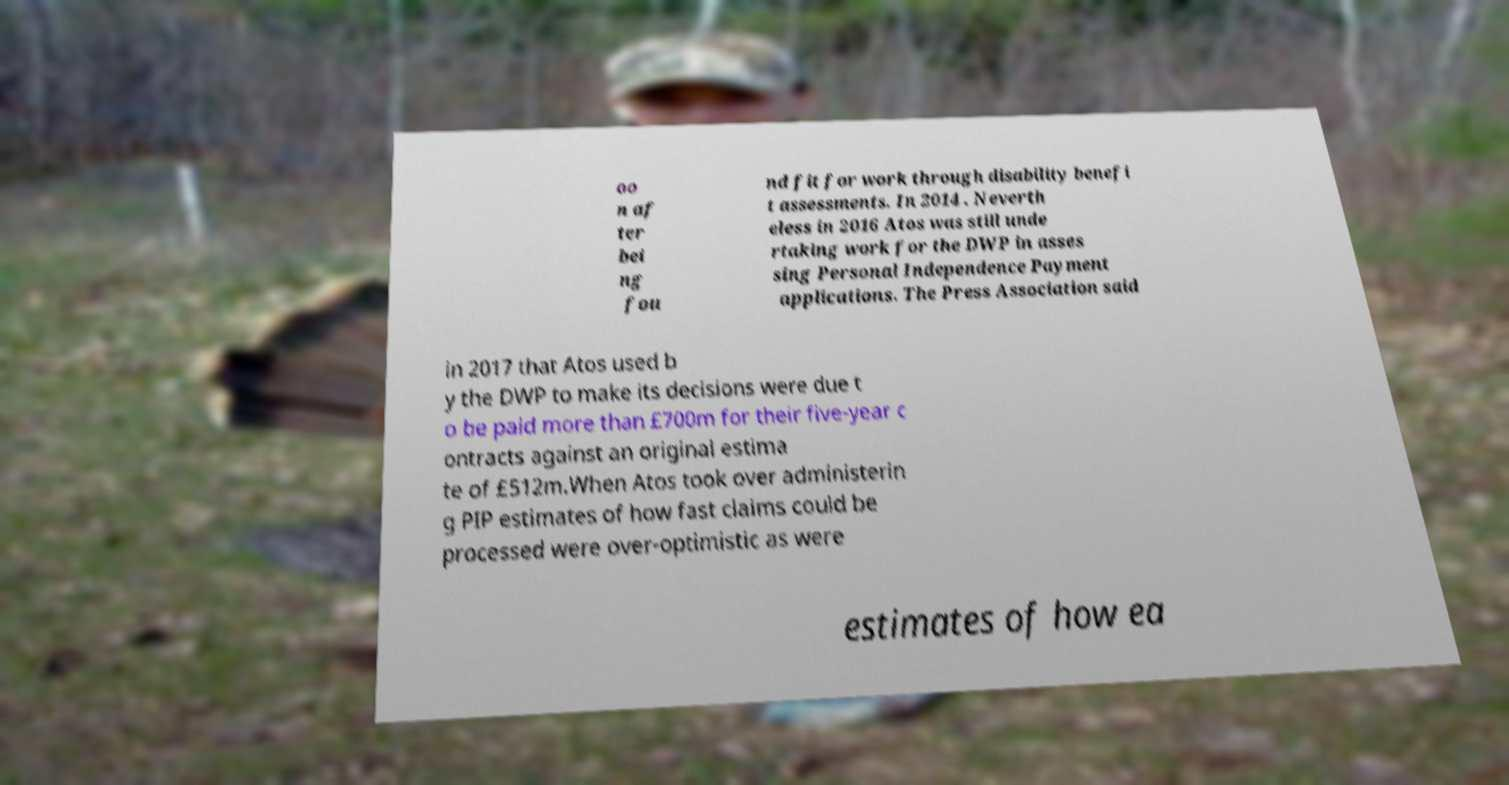Can you accurately transcribe the text from the provided image for me? oo n af ter bei ng fou nd fit for work through disability benefi t assessments. In 2014 . Neverth eless in 2016 Atos was still unde rtaking work for the DWP in asses sing Personal Independence Payment applications. The Press Association said in 2017 that Atos used b y the DWP to make its decisions were due t o be paid more than £700m for their five-year c ontracts against an original estima te of £512m.When Atos took over administerin g PIP estimates of how fast claims could be processed were over-optimistic as were estimates of how ea 